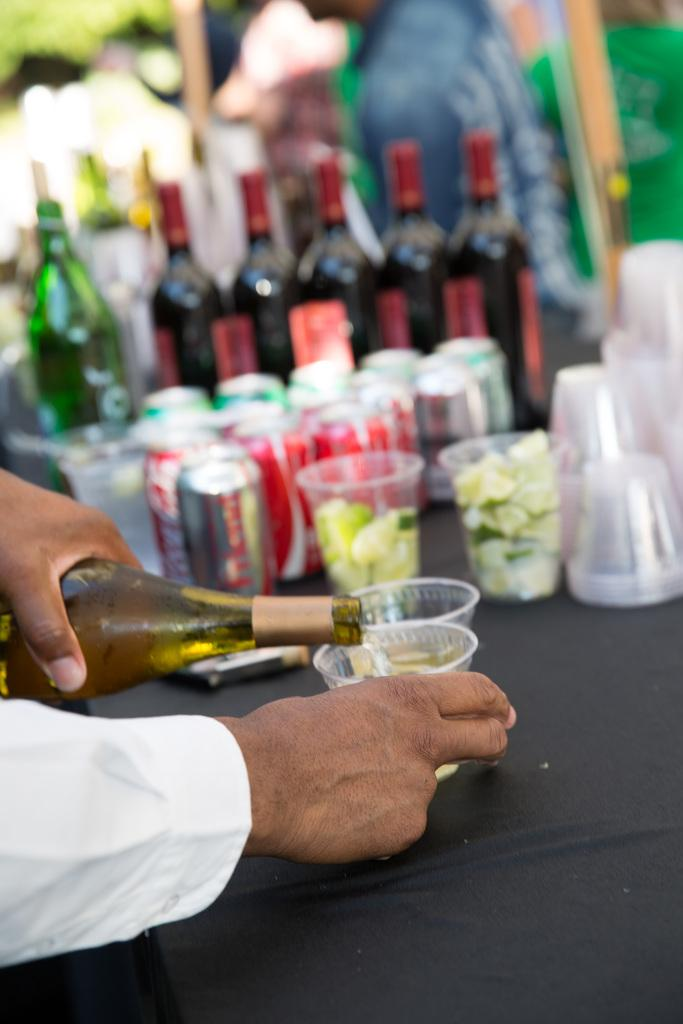<image>
Present a compact description of the photo's key features. Four unopened cans of coca-cola are sitting on a table. 